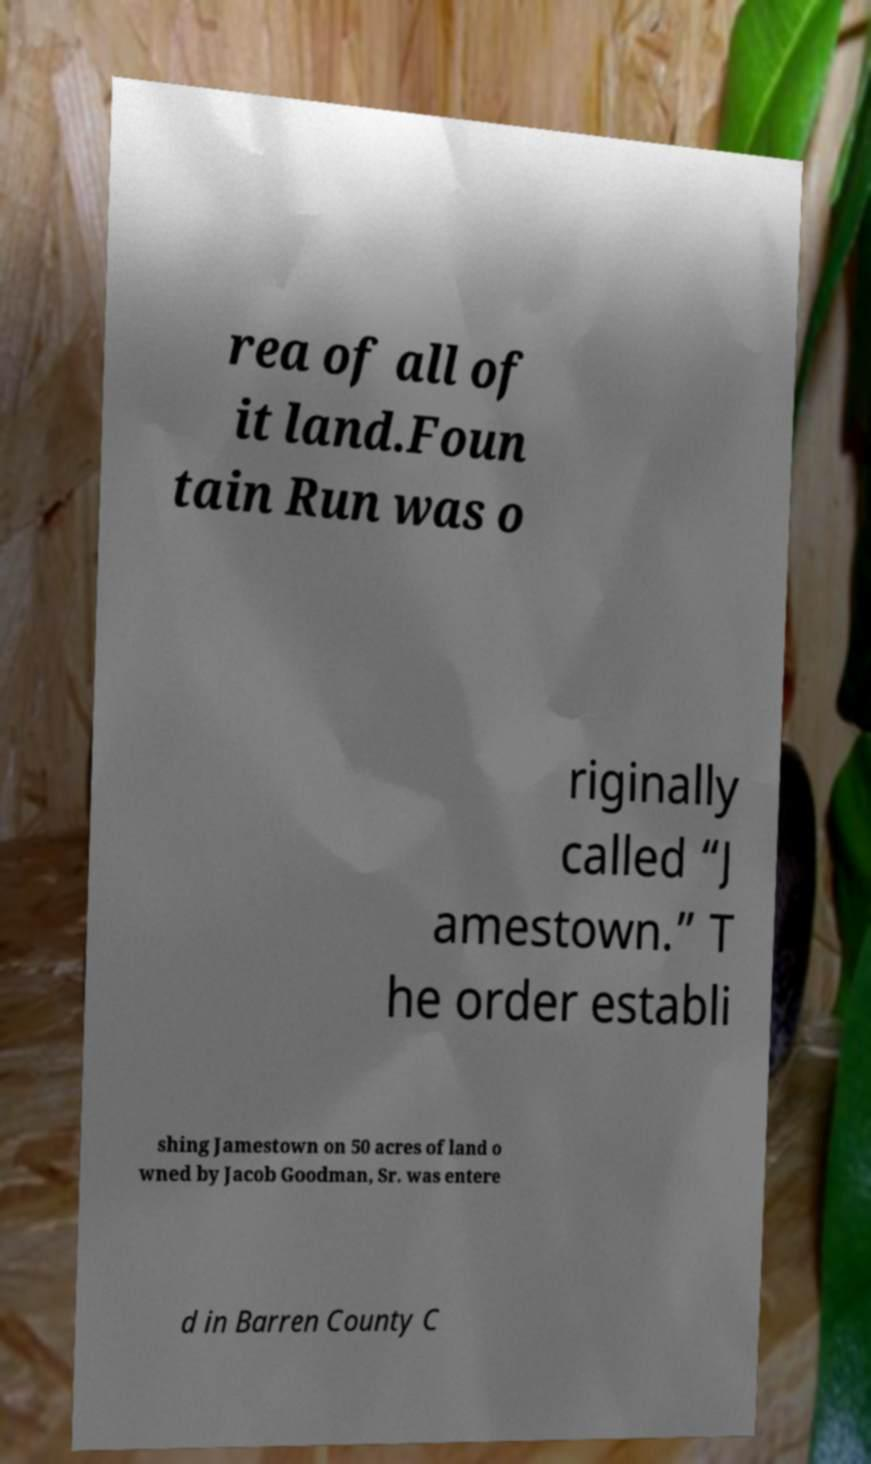For documentation purposes, I need the text within this image transcribed. Could you provide that? rea of all of it land.Foun tain Run was o riginally called “J amestown.” T he order establi shing Jamestown on 50 acres of land o wned by Jacob Goodman, Sr. was entere d in Barren County C 